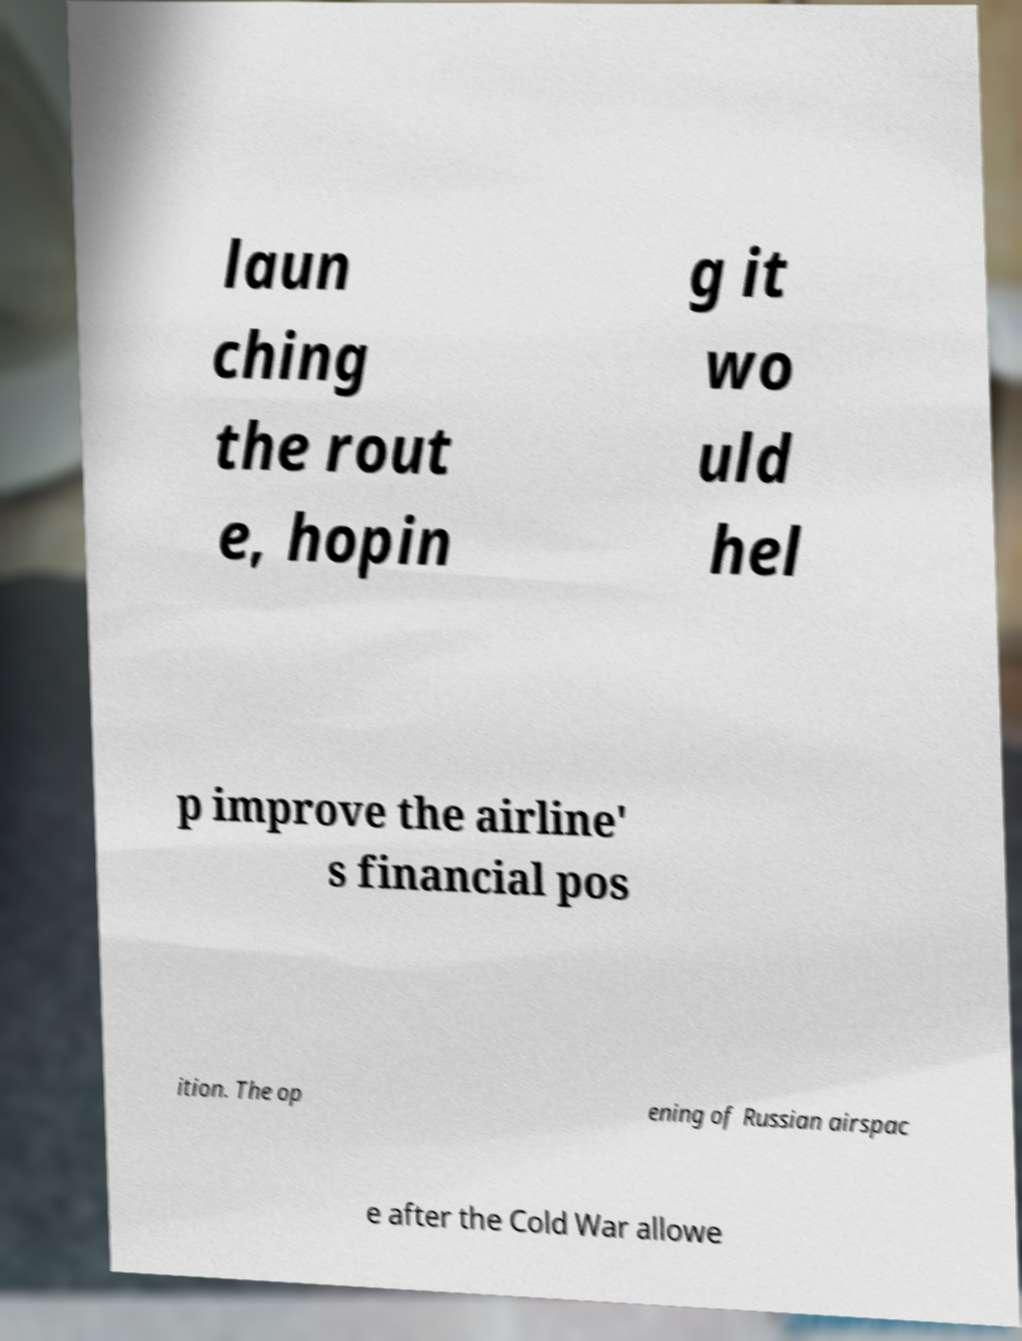There's text embedded in this image that I need extracted. Can you transcribe it verbatim? laun ching the rout e, hopin g it wo uld hel p improve the airline' s financial pos ition. The op ening of Russian airspac e after the Cold War allowe 